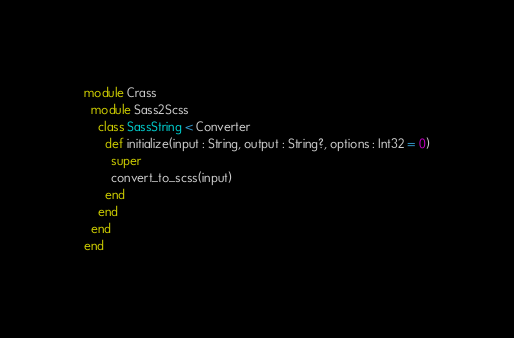Convert code to text. <code><loc_0><loc_0><loc_500><loc_500><_Crystal_>module Crass
  module Sass2Scss
    class SassString < Converter
      def initialize(input : String, output : String?, options : Int32 = 0)
        super
        convert_to_scss(input)
      end
    end
  end
end
</code> 